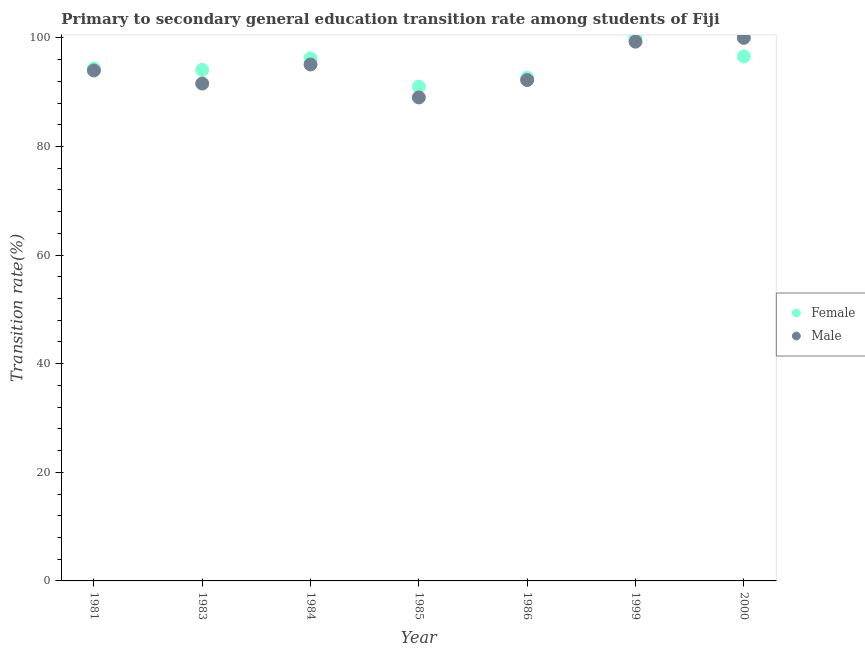Is the number of dotlines equal to the number of legend labels?
Your answer should be compact. Yes. What is the transition rate among male students in 1986?
Provide a short and direct response. 92.23. Across all years, what is the minimum transition rate among male students?
Ensure brevity in your answer.  89.03. What is the total transition rate among female students in the graph?
Offer a very short reply. 664.92. What is the difference between the transition rate among female students in 1981 and that in 2000?
Your answer should be very brief. -2.22. What is the difference between the transition rate among male students in 1986 and the transition rate among female students in 2000?
Give a very brief answer. -4.34. What is the average transition rate among female students per year?
Your answer should be very brief. 94.99. In the year 1999, what is the difference between the transition rate among female students and transition rate among male students?
Ensure brevity in your answer.  0.7. What is the ratio of the transition rate among male students in 1981 to that in 1983?
Keep it short and to the point. 1.03. Is the transition rate among male students in 1983 less than that in 1984?
Offer a terse response. Yes. What is the difference between the highest and the second highest transition rate among female students?
Keep it short and to the point. 3.43. What is the difference between the highest and the lowest transition rate among male students?
Keep it short and to the point. 10.97. In how many years, is the transition rate among male students greater than the average transition rate among male students taken over all years?
Offer a very short reply. 3. Is the transition rate among male students strictly greater than the transition rate among female students over the years?
Keep it short and to the point. No. Does the graph contain any zero values?
Offer a very short reply. No. How many legend labels are there?
Provide a succinct answer. 2. What is the title of the graph?
Offer a terse response. Primary to secondary general education transition rate among students of Fiji. Does "Age 65(female)" appear as one of the legend labels in the graph?
Keep it short and to the point. No. What is the label or title of the Y-axis?
Your answer should be very brief. Transition rate(%). What is the Transition rate(%) of Female in 1981?
Make the answer very short. 94.36. What is the Transition rate(%) in Male in 1981?
Your answer should be very brief. 93.99. What is the Transition rate(%) of Female in 1983?
Provide a succinct answer. 94.1. What is the Transition rate(%) of Male in 1983?
Provide a short and direct response. 91.59. What is the Transition rate(%) in Female in 1984?
Make the answer very short. 96.22. What is the Transition rate(%) of Male in 1984?
Your answer should be compact. 95.1. What is the Transition rate(%) in Female in 1985?
Make the answer very short. 91.02. What is the Transition rate(%) in Male in 1985?
Provide a succinct answer. 89.03. What is the Transition rate(%) of Female in 1986?
Your response must be concise. 92.65. What is the Transition rate(%) of Male in 1986?
Offer a terse response. 92.23. What is the Transition rate(%) of Female in 1999?
Ensure brevity in your answer.  100. What is the Transition rate(%) in Male in 1999?
Offer a terse response. 99.3. What is the Transition rate(%) in Female in 2000?
Offer a very short reply. 96.57. Across all years, what is the maximum Transition rate(%) of Male?
Provide a short and direct response. 100. Across all years, what is the minimum Transition rate(%) in Female?
Your answer should be very brief. 91.02. Across all years, what is the minimum Transition rate(%) of Male?
Your answer should be very brief. 89.03. What is the total Transition rate(%) of Female in the graph?
Ensure brevity in your answer.  664.92. What is the total Transition rate(%) in Male in the graph?
Ensure brevity in your answer.  661.24. What is the difference between the Transition rate(%) of Female in 1981 and that in 1983?
Your answer should be very brief. 0.26. What is the difference between the Transition rate(%) of Male in 1981 and that in 1983?
Offer a terse response. 2.41. What is the difference between the Transition rate(%) in Female in 1981 and that in 1984?
Offer a terse response. -1.86. What is the difference between the Transition rate(%) of Male in 1981 and that in 1984?
Ensure brevity in your answer.  -1.11. What is the difference between the Transition rate(%) in Female in 1981 and that in 1985?
Provide a short and direct response. 3.34. What is the difference between the Transition rate(%) of Male in 1981 and that in 1985?
Your answer should be compact. 4.97. What is the difference between the Transition rate(%) of Female in 1981 and that in 1986?
Provide a succinct answer. 1.71. What is the difference between the Transition rate(%) of Male in 1981 and that in 1986?
Provide a succinct answer. 1.76. What is the difference between the Transition rate(%) of Female in 1981 and that in 1999?
Your answer should be very brief. -5.64. What is the difference between the Transition rate(%) in Male in 1981 and that in 1999?
Make the answer very short. -5.31. What is the difference between the Transition rate(%) in Female in 1981 and that in 2000?
Give a very brief answer. -2.22. What is the difference between the Transition rate(%) in Male in 1981 and that in 2000?
Provide a succinct answer. -6.01. What is the difference between the Transition rate(%) of Female in 1983 and that in 1984?
Give a very brief answer. -2.12. What is the difference between the Transition rate(%) in Male in 1983 and that in 1984?
Make the answer very short. -3.51. What is the difference between the Transition rate(%) of Female in 1983 and that in 1985?
Offer a very short reply. 3.08. What is the difference between the Transition rate(%) of Male in 1983 and that in 1985?
Make the answer very short. 2.56. What is the difference between the Transition rate(%) in Female in 1983 and that in 1986?
Provide a short and direct response. 1.45. What is the difference between the Transition rate(%) of Male in 1983 and that in 1986?
Provide a short and direct response. -0.65. What is the difference between the Transition rate(%) in Male in 1983 and that in 1999?
Your answer should be very brief. -7.71. What is the difference between the Transition rate(%) in Female in 1983 and that in 2000?
Provide a succinct answer. -2.47. What is the difference between the Transition rate(%) of Male in 1983 and that in 2000?
Give a very brief answer. -8.41. What is the difference between the Transition rate(%) of Female in 1984 and that in 1985?
Ensure brevity in your answer.  5.2. What is the difference between the Transition rate(%) in Male in 1984 and that in 1985?
Make the answer very short. 6.07. What is the difference between the Transition rate(%) of Female in 1984 and that in 1986?
Ensure brevity in your answer.  3.57. What is the difference between the Transition rate(%) in Male in 1984 and that in 1986?
Your answer should be very brief. 2.87. What is the difference between the Transition rate(%) of Female in 1984 and that in 1999?
Provide a short and direct response. -3.78. What is the difference between the Transition rate(%) of Male in 1984 and that in 1999?
Your response must be concise. -4.2. What is the difference between the Transition rate(%) in Female in 1984 and that in 2000?
Provide a succinct answer. -0.35. What is the difference between the Transition rate(%) in Male in 1984 and that in 2000?
Your response must be concise. -4.9. What is the difference between the Transition rate(%) of Female in 1985 and that in 1986?
Your answer should be compact. -1.63. What is the difference between the Transition rate(%) of Male in 1985 and that in 1986?
Give a very brief answer. -3.21. What is the difference between the Transition rate(%) in Female in 1985 and that in 1999?
Your answer should be compact. -8.98. What is the difference between the Transition rate(%) of Male in 1985 and that in 1999?
Offer a very short reply. -10.27. What is the difference between the Transition rate(%) of Female in 1985 and that in 2000?
Provide a succinct answer. -5.55. What is the difference between the Transition rate(%) of Male in 1985 and that in 2000?
Ensure brevity in your answer.  -10.97. What is the difference between the Transition rate(%) in Female in 1986 and that in 1999?
Offer a very short reply. -7.35. What is the difference between the Transition rate(%) of Male in 1986 and that in 1999?
Your answer should be very brief. -7.07. What is the difference between the Transition rate(%) in Female in 1986 and that in 2000?
Keep it short and to the point. -3.92. What is the difference between the Transition rate(%) in Male in 1986 and that in 2000?
Make the answer very short. -7.77. What is the difference between the Transition rate(%) of Female in 1999 and that in 2000?
Give a very brief answer. 3.43. What is the difference between the Transition rate(%) in Male in 1999 and that in 2000?
Your answer should be compact. -0.7. What is the difference between the Transition rate(%) in Female in 1981 and the Transition rate(%) in Male in 1983?
Ensure brevity in your answer.  2.77. What is the difference between the Transition rate(%) of Female in 1981 and the Transition rate(%) of Male in 1984?
Make the answer very short. -0.74. What is the difference between the Transition rate(%) in Female in 1981 and the Transition rate(%) in Male in 1985?
Provide a succinct answer. 5.33. What is the difference between the Transition rate(%) in Female in 1981 and the Transition rate(%) in Male in 1986?
Provide a short and direct response. 2.12. What is the difference between the Transition rate(%) in Female in 1981 and the Transition rate(%) in Male in 1999?
Provide a succinct answer. -4.94. What is the difference between the Transition rate(%) of Female in 1981 and the Transition rate(%) of Male in 2000?
Your response must be concise. -5.64. What is the difference between the Transition rate(%) in Female in 1983 and the Transition rate(%) in Male in 1984?
Provide a short and direct response. -1. What is the difference between the Transition rate(%) in Female in 1983 and the Transition rate(%) in Male in 1985?
Offer a very short reply. 5.07. What is the difference between the Transition rate(%) of Female in 1983 and the Transition rate(%) of Male in 1986?
Provide a short and direct response. 1.87. What is the difference between the Transition rate(%) in Female in 1983 and the Transition rate(%) in Male in 2000?
Your response must be concise. -5.9. What is the difference between the Transition rate(%) of Female in 1984 and the Transition rate(%) of Male in 1985?
Offer a very short reply. 7.19. What is the difference between the Transition rate(%) in Female in 1984 and the Transition rate(%) in Male in 1986?
Offer a very short reply. 3.98. What is the difference between the Transition rate(%) of Female in 1984 and the Transition rate(%) of Male in 1999?
Make the answer very short. -3.08. What is the difference between the Transition rate(%) in Female in 1984 and the Transition rate(%) in Male in 2000?
Make the answer very short. -3.78. What is the difference between the Transition rate(%) of Female in 1985 and the Transition rate(%) of Male in 1986?
Provide a short and direct response. -1.21. What is the difference between the Transition rate(%) in Female in 1985 and the Transition rate(%) in Male in 1999?
Offer a very short reply. -8.28. What is the difference between the Transition rate(%) of Female in 1985 and the Transition rate(%) of Male in 2000?
Give a very brief answer. -8.98. What is the difference between the Transition rate(%) of Female in 1986 and the Transition rate(%) of Male in 1999?
Ensure brevity in your answer.  -6.65. What is the difference between the Transition rate(%) in Female in 1986 and the Transition rate(%) in Male in 2000?
Provide a succinct answer. -7.35. What is the difference between the Transition rate(%) of Female in 1999 and the Transition rate(%) of Male in 2000?
Make the answer very short. 0. What is the average Transition rate(%) in Female per year?
Offer a very short reply. 94.99. What is the average Transition rate(%) of Male per year?
Give a very brief answer. 94.46. In the year 1981, what is the difference between the Transition rate(%) in Female and Transition rate(%) in Male?
Provide a short and direct response. 0.36. In the year 1983, what is the difference between the Transition rate(%) in Female and Transition rate(%) in Male?
Provide a succinct answer. 2.51. In the year 1984, what is the difference between the Transition rate(%) in Female and Transition rate(%) in Male?
Your answer should be very brief. 1.12. In the year 1985, what is the difference between the Transition rate(%) of Female and Transition rate(%) of Male?
Offer a terse response. 1.99. In the year 1986, what is the difference between the Transition rate(%) of Female and Transition rate(%) of Male?
Provide a short and direct response. 0.42. In the year 2000, what is the difference between the Transition rate(%) of Female and Transition rate(%) of Male?
Your answer should be very brief. -3.43. What is the ratio of the Transition rate(%) of Female in 1981 to that in 1983?
Keep it short and to the point. 1. What is the ratio of the Transition rate(%) of Male in 1981 to that in 1983?
Offer a very short reply. 1.03. What is the ratio of the Transition rate(%) of Female in 1981 to that in 1984?
Give a very brief answer. 0.98. What is the ratio of the Transition rate(%) of Male in 1981 to that in 1984?
Offer a very short reply. 0.99. What is the ratio of the Transition rate(%) of Female in 1981 to that in 1985?
Provide a short and direct response. 1.04. What is the ratio of the Transition rate(%) of Male in 1981 to that in 1985?
Provide a short and direct response. 1.06. What is the ratio of the Transition rate(%) in Female in 1981 to that in 1986?
Your answer should be compact. 1.02. What is the ratio of the Transition rate(%) in Male in 1981 to that in 1986?
Provide a succinct answer. 1.02. What is the ratio of the Transition rate(%) of Female in 1981 to that in 1999?
Your response must be concise. 0.94. What is the ratio of the Transition rate(%) in Male in 1981 to that in 1999?
Make the answer very short. 0.95. What is the ratio of the Transition rate(%) in Female in 1981 to that in 2000?
Provide a succinct answer. 0.98. What is the ratio of the Transition rate(%) of Male in 1981 to that in 2000?
Make the answer very short. 0.94. What is the ratio of the Transition rate(%) of Male in 1983 to that in 1984?
Your answer should be compact. 0.96. What is the ratio of the Transition rate(%) in Female in 1983 to that in 1985?
Offer a very short reply. 1.03. What is the ratio of the Transition rate(%) of Male in 1983 to that in 1985?
Make the answer very short. 1.03. What is the ratio of the Transition rate(%) in Female in 1983 to that in 1986?
Make the answer very short. 1.02. What is the ratio of the Transition rate(%) of Female in 1983 to that in 1999?
Keep it short and to the point. 0.94. What is the ratio of the Transition rate(%) of Male in 1983 to that in 1999?
Provide a succinct answer. 0.92. What is the ratio of the Transition rate(%) in Female in 1983 to that in 2000?
Ensure brevity in your answer.  0.97. What is the ratio of the Transition rate(%) of Male in 1983 to that in 2000?
Provide a succinct answer. 0.92. What is the ratio of the Transition rate(%) of Female in 1984 to that in 1985?
Ensure brevity in your answer.  1.06. What is the ratio of the Transition rate(%) in Male in 1984 to that in 1985?
Offer a terse response. 1.07. What is the ratio of the Transition rate(%) of Female in 1984 to that in 1986?
Your answer should be compact. 1.04. What is the ratio of the Transition rate(%) of Male in 1984 to that in 1986?
Your answer should be compact. 1.03. What is the ratio of the Transition rate(%) of Female in 1984 to that in 1999?
Give a very brief answer. 0.96. What is the ratio of the Transition rate(%) of Male in 1984 to that in 1999?
Provide a succinct answer. 0.96. What is the ratio of the Transition rate(%) of Female in 1984 to that in 2000?
Your answer should be compact. 1. What is the ratio of the Transition rate(%) in Male in 1984 to that in 2000?
Make the answer very short. 0.95. What is the ratio of the Transition rate(%) in Female in 1985 to that in 1986?
Make the answer very short. 0.98. What is the ratio of the Transition rate(%) in Male in 1985 to that in 1986?
Provide a short and direct response. 0.97. What is the ratio of the Transition rate(%) of Female in 1985 to that in 1999?
Give a very brief answer. 0.91. What is the ratio of the Transition rate(%) in Male in 1985 to that in 1999?
Your response must be concise. 0.9. What is the ratio of the Transition rate(%) of Female in 1985 to that in 2000?
Offer a terse response. 0.94. What is the ratio of the Transition rate(%) of Male in 1985 to that in 2000?
Your response must be concise. 0.89. What is the ratio of the Transition rate(%) of Female in 1986 to that in 1999?
Ensure brevity in your answer.  0.93. What is the ratio of the Transition rate(%) in Male in 1986 to that in 1999?
Give a very brief answer. 0.93. What is the ratio of the Transition rate(%) of Female in 1986 to that in 2000?
Provide a succinct answer. 0.96. What is the ratio of the Transition rate(%) of Male in 1986 to that in 2000?
Keep it short and to the point. 0.92. What is the ratio of the Transition rate(%) in Female in 1999 to that in 2000?
Make the answer very short. 1.04. What is the difference between the highest and the second highest Transition rate(%) of Female?
Provide a succinct answer. 3.43. What is the difference between the highest and the second highest Transition rate(%) of Male?
Your answer should be compact. 0.7. What is the difference between the highest and the lowest Transition rate(%) of Female?
Keep it short and to the point. 8.98. What is the difference between the highest and the lowest Transition rate(%) of Male?
Ensure brevity in your answer.  10.97. 